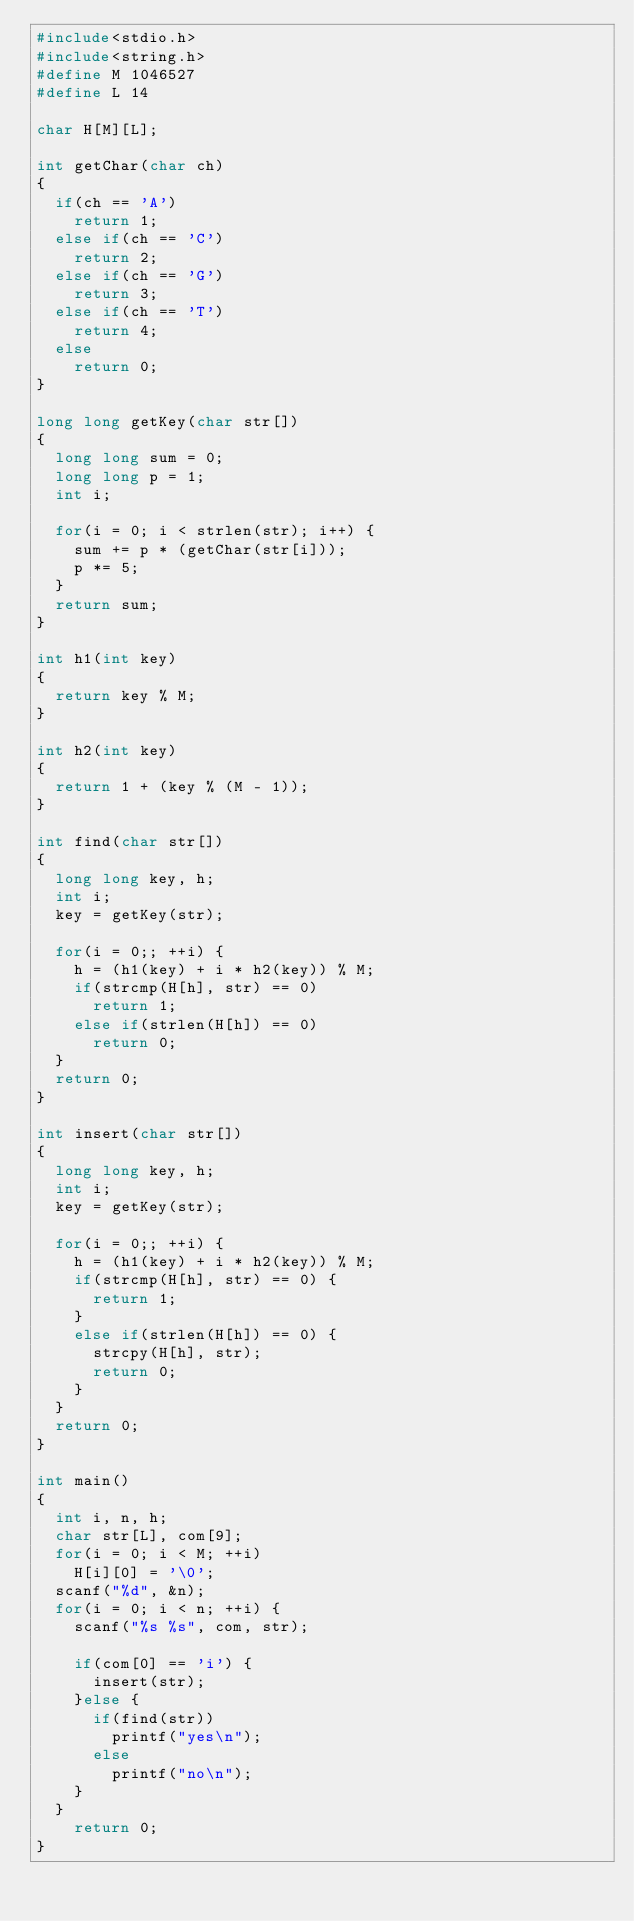<code> <loc_0><loc_0><loc_500><loc_500><_C_>#include<stdio.h>
#include<string.h>
#define M 1046527
#define L 14

char H[M][L];

int getChar(char ch)
{
	if(ch == 'A')
		return 1;
	else if(ch == 'C')
		return 2;
	else if(ch == 'G')
		return 3;
	else if(ch == 'T')
		return 4;
	else
		return 0;
}

long long getKey(char str[])
{
	long long sum = 0;
	long long p = 1;
	int i;

	for(i = 0; i < strlen(str); i++) {
		sum += p * (getChar(str[i]));
		p *= 5;
	}
	return sum;
}

int h1(int key)
{
	return key % M;
}

int h2(int key)
{
	return 1 + (key % (M - 1));
}

int find(char str[])
{
	long long key, h;
	int i;
	key = getKey(str);

	for(i = 0;; ++i) {
		h = (h1(key) + i * h2(key)) % M;
		if(strcmp(H[h], str) == 0)
			return 1;
		else if(strlen(H[h]) == 0)
			return 0;
	}
	return 0;
}

int insert(char str[])
{
	long long key, h;
	int i;
	key = getKey(str);

	for(i = 0;; ++i) {
		h = (h1(key) + i * h2(key)) % M;
		if(strcmp(H[h], str) == 0) {
			return 1;
		}
		else if(strlen(H[h]) == 0) {
			strcpy(H[h], str);
			return 0;
		}
	}
	return 0;
}

int main()
{	
	int i, n, h;
	char str[L], com[9];
	for(i = 0; i < M; ++i)
		H[i][0] = '\0';
	scanf("%d", &n);
	for(i = 0; i < n; ++i) {
		scanf("%s %s", com, str);

		if(com[0] == 'i') {
			insert(str);
		}else {
			if(find(str))
				printf("yes\n");
			else
				printf("no\n");
		}
	}
    return 0;
}</code> 